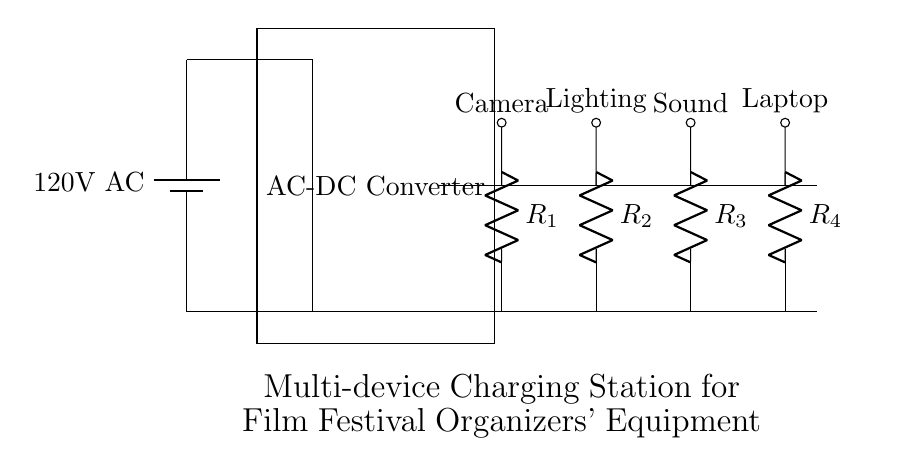What is the input voltage of the circuit? The input voltage is labeled as 120V AC, indicating the power source that powers the charging station.
Answer: 120V AC What are the devices being charged? The devices are indicated by the labels connected to the charging ports: Camera, Lighting, Sound, and Laptop.
Answer: Camera, Lighting, Sound, Laptop How many resistors are present in the circuit? There are four resistors in the circuit, each connected to a different charging port to limit the current to the respective devices.
Answer: Four What is the role of the AC-DC converter in this circuit? The AC-DC converter is responsible for converting the alternating current input from the battery into direct current suitable for charging electronic devices.
Answer: Convert AC to DC Which component connects all charging ports to the power source? The distribution bus connects all charging ports to the power source, allowing the converted power to be distributed evenly to each port.
Answer: Distribution bus If one device requires more current than the others, how is this managed? Current limiting resistors (R1, R2, R3, R4) control the current flowing to each device, preventing overload on any single charger.
Answer: Current limiting resistors What is the purpose of grounding in this circuit? Grounding provides a safe path for excess current or faults, ensuring the safety of users by preventing electric shocks.
Answer: Safety 